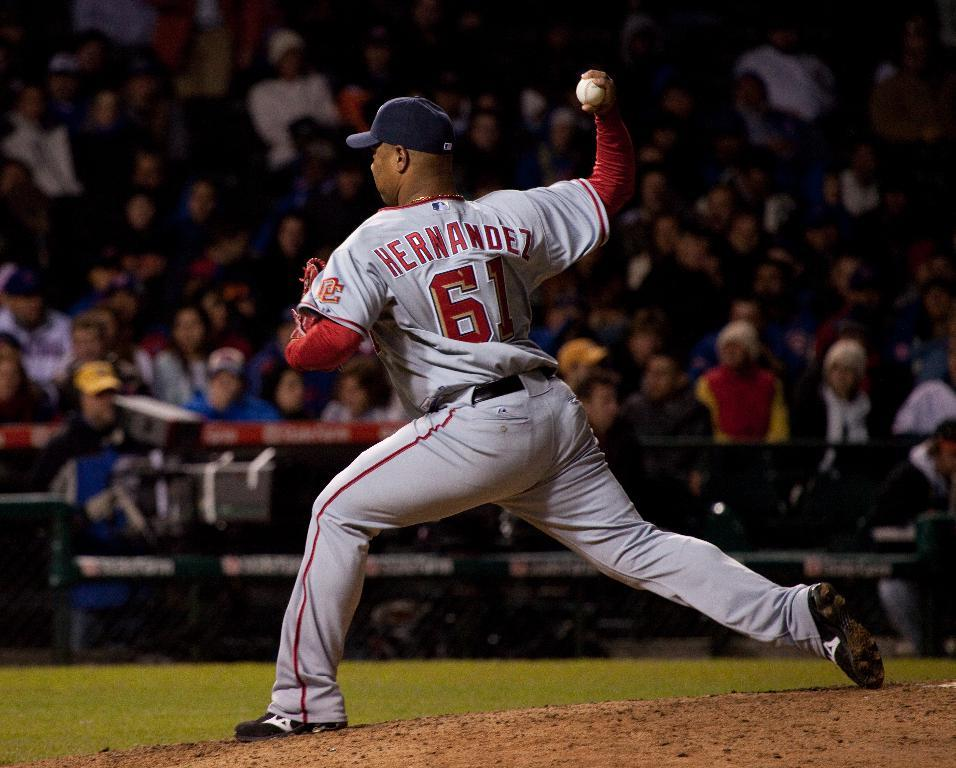<image>
Relay a brief, clear account of the picture shown. A pitcher name Hernandez throwing a ball withhis right hand 